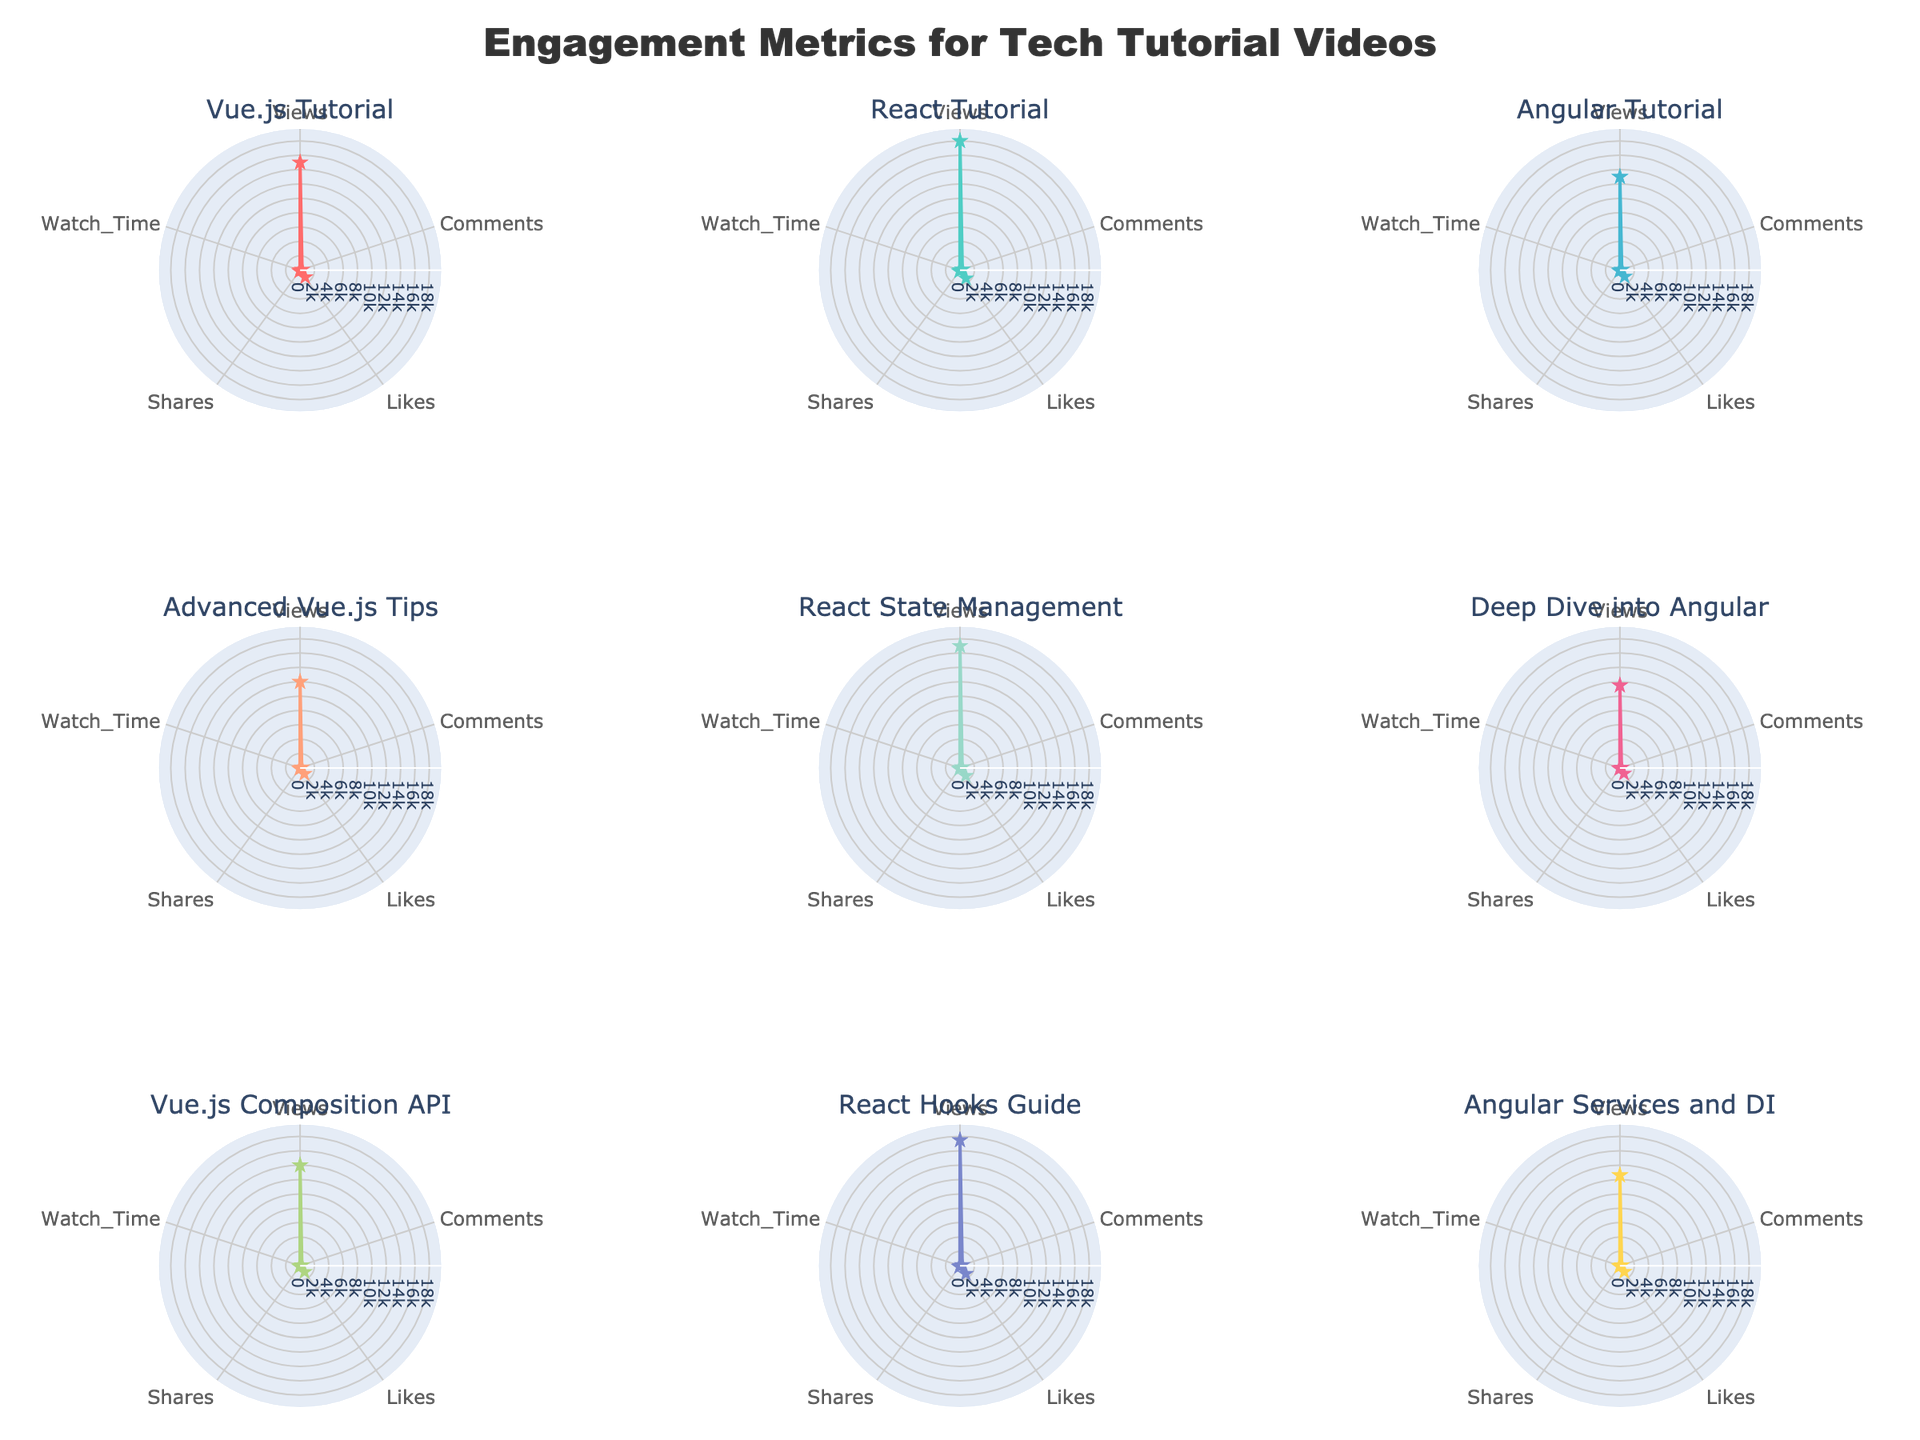What is the title of the radar chart? The title is usually found at the top of the figure. The radar chart's title is indicated as "Engagement Metrics for Tech Tutorial Videos".
Answer: Engagement Metrics for Tech Tutorial Videos Which tech tutorial had the highest number of views? To determine this, look for the radar chart with the largest "Views" value. The React Tutorial has the highest value.
Answer: React Tutorial Compare the likes and shares for the "Angular Tutorial" and "Vue.js Tutorial". Which one has higher engagement in these metrics? Look at the corresponding radar charts. The "Vue.js Tutorial" has more likes (1200) and shares (150) compared to the "Angular Tutorial" (1100 likes and 120 shares).
Answer: Vue.js Tutorial Which topic had the least number of comments? Determine the radar chart with the smallest number of comments. "Deep Dive into Angular" has the least number of comments according to the value on the radial axis.
Answer: Deep Dive into Angular What is the average watch time across all tutorials? Calculate the sum of the watch times (20, 25, 18, 22, 24, 19, 21, 26, 20) and divide by the number of tutorials (9). The calculation is (20 + 25 + 18 + 22 + 24 + 19 + 21 + 26 + 20) / 9 = 195 / 9 ≈ 21.67.
Answer: 21.67 How does the engagement for "React Hooks Guide" compare to the "Advanced Vue.js Tips" in terms of likes? Look at both radar charts. "React Hooks Guide" has 1380 likes, whereas "Advanced Vue.js Tips" has 1000 likes, which means "React Hooks Guide" has higher engagement in likes.
Answer: React Hooks Guide Is the watch time for "Vue.js Composition API" higher than the watch time for "Angular Services and DI"? Compare the values. "Vue.js Composition API" has a watch time of 21 while "Angular Services and DI" has a watch time of 20.
Answer: Yes Which tech topic has the most balanced engagement across all metrics? To find this, look for the topic whose radar chart is the most circular or evenly distributed. The "React Hooks Guide" seems to have a balanced engagement across views, comments, likes, shares, and watch time.
Answer: React Hooks Guide What is the total number of shares for all tutorials combined? Sum the shares from all topics (150 + 180 + 120 + 130 + 170 + 110 + 140 + 175 + 115). The total is 1290.
Answer: 1290 